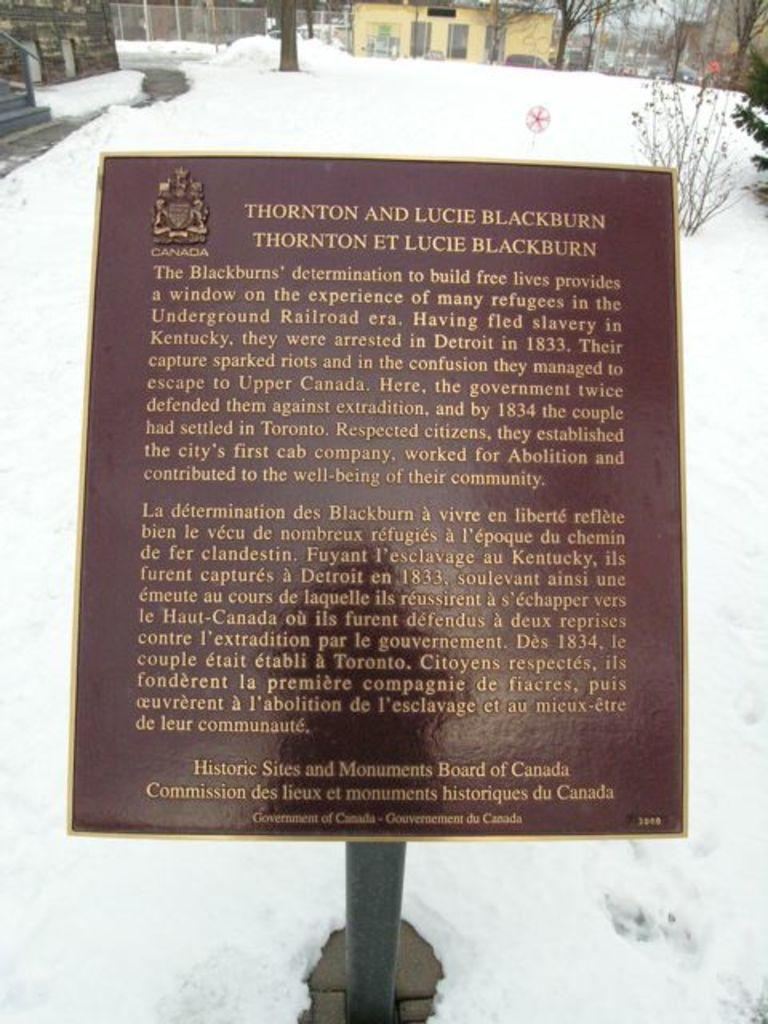What is the main object in the foreground of the image? There is a name board in the foreground of the image. What is the condition of the environment around the name board? The name board is surrounded by snow. What can be seen in the background of the image? There is a plant, trees, houses, and a fencing in the background of the image. What is the rabbit's interest in the time displayed on the name board? There is no rabbit present in the image, and therefore no such interaction can be observed. 